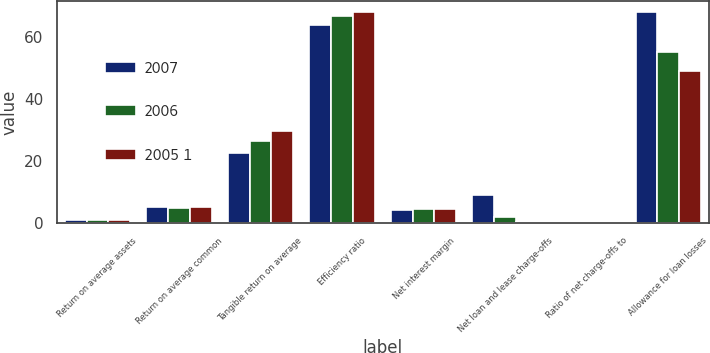Convert chart to OTSL. <chart><loc_0><loc_0><loc_500><loc_500><stacked_bar_chart><ecel><fcel>Return on average assets<fcel>Return on average common<fcel>Tangible return on average<fcel>Efficiency ratio<fcel>Net interest margin<fcel>Net loan and lease charge-offs<fcel>Ratio of net charge-offs to<fcel>Allowance for loan losses<nl><fcel>2007<fcel>0.91<fcel>5.1<fcel>22.46<fcel>63.83<fcel>4.13<fcel>9<fcel>0.13<fcel>68<nl><fcel>2006<fcel>0.93<fcel>4.87<fcel>26.25<fcel>66.79<fcel>4.36<fcel>1.9<fcel>0.03<fcel>55<nl><fcel>2005 1<fcel>0.97<fcel>4.97<fcel>29.72<fcel>68.03<fcel>4.44<fcel>0.2<fcel>0.04<fcel>49<nl></chart> 